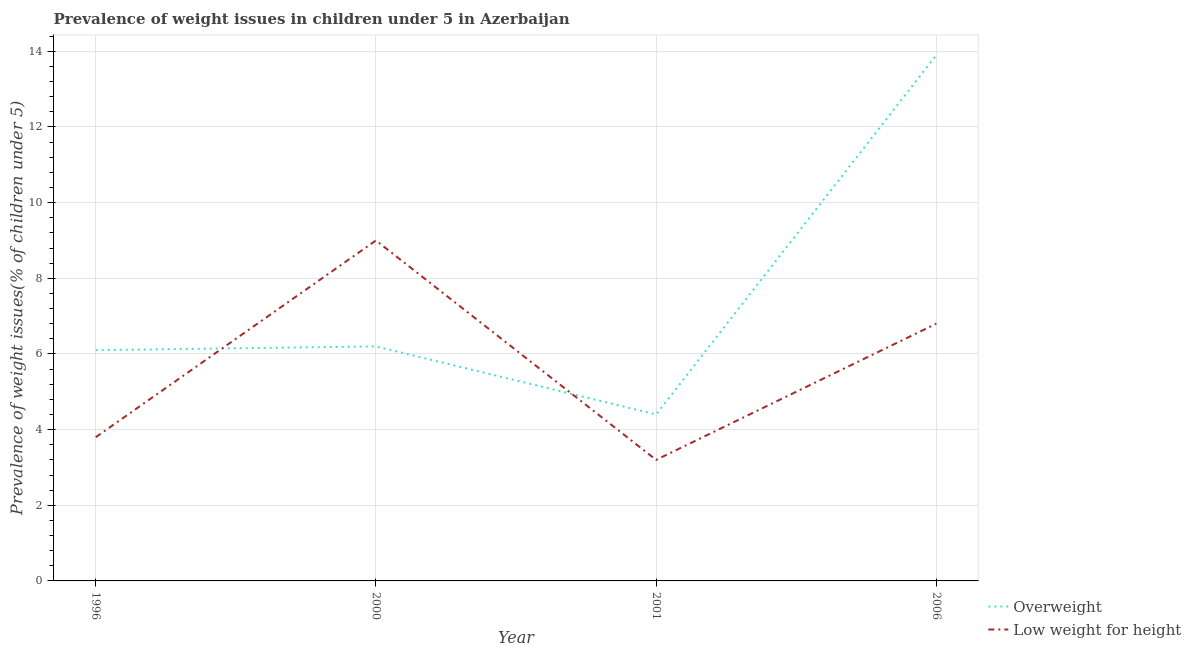What is the percentage of underweight children in 1996?
Offer a very short reply. 3.8. Across all years, what is the minimum percentage of overweight children?
Provide a short and direct response. 4.4. In which year was the percentage of overweight children maximum?
Offer a terse response. 2006. In which year was the percentage of overweight children minimum?
Give a very brief answer. 2001. What is the total percentage of underweight children in the graph?
Offer a terse response. 22.8. What is the difference between the percentage of underweight children in 1996 and that in 2000?
Your answer should be very brief. -5.2. What is the difference between the percentage of underweight children in 1996 and the percentage of overweight children in 2000?
Your answer should be compact. -2.4. What is the average percentage of underweight children per year?
Offer a very short reply. 5.7. In the year 2000, what is the difference between the percentage of overweight children and percentage of underweight children?
Your response must be concise. -2.8. In how many years, is the percentage of overweight children greater than 14 %?
Make the answer very short. 0. What is the ratio of the percentage of overweight children in 2001 to that in 2006?
Keep it short and to the point. 0.32. Is the percentage of overweight children in 1996 less than that in 2006?
Your answer should be compact. Yes. What is the difference between the highest and the second highest percentage of overweight children?
Your answer should be very brief. 7.7. What is the difference between the highest and the lowest percentage of overweight children?
Ensure brevity in your answer.  9.5. How many lines are there?
Make the answer very short. 2. How many years are there in the graph?
Make the answer very short. 4. Are the values on the major ticks of Y-axis written in scientific E-notation?
Ensure brevity in your answer.  No. Does the graph contain any zero values?
Give a very brief answer. No. Does the graph contain grids?
Your answer should be very brief. Yes. What is the title of the graph?
Give a very brief answer. Prevalence of weight issues in children under 5 in Azerbaijan. What is the label or title of the Y-axis?
Your answer should be very brief. Prevalence of weight issues(% of children under 5). What is the Prevalence of weight issues(% of children under 5) of Overweight in 1996?
Make the answer very short. 6.1. What is the Prevalence of weight issues(% of children under 5) in Low weight for height in 1996?
Provide a short and direct response. 3.8. What is the Prevalence of weight issues(% of children under 5) in Overweight in 2000?
Provide a succinct answer. 6.2. What is the Prevalence of weight issues(% of children under 5) in Low weight for height in 2000?
Offer a very short reply. 9. What is the Prevalence of weight issues(% of children under 5) of Overweight in 2001?
Provide a succinct answer. 4.4. What is the Prevalence of weight issues(% of children under 5) in Low weight for height in 2001?
Your response must be concise. 3.2. What is the Prevalence of weight issues(% of children under 5) in Overweight in 2006?
Your answer should be very brief. 13.9. What is the Prevalence of weight issues(% of children under 5) of Low weight for height in 2006?
Your answer should be compact. 6.8. Across all years, what is the maximum Prevalence of weight issues(% of children under 5) in Overweight?
Give a very brief answer. 13.9. Across all years, what is the maximum Prevalence of weight issues(% of children under 5) of Low weight for height?
Make the answer very short. 9. Across all years, what is the minimum Prevalence of weight issues(% of children under 5) of Overweight?
Offer a very short reply. 4.4. Across all years, what is the minimum Prevalence of weight issues(% of children under 5) of Low weight for height?
Your answer should be very brief. 3.2. What is the total Prevalence of weight issues(% of children under 5) of Overweight in the graph?
Give a very brief answer. 30.6. What is the total Prevalence of weight issues(% of children under 5) in Low weight for height in the graph?
Keep it short and to the point. 22.8. What is the difference between the Prevalence of weight issues(% of children under 5) of Overweight in 1996 and that in 2000?
Provide a succinct answer. -0.1. What is the difference between the Prevalence of weight issues(% of children under 5) in Overweight in 1996 and that in 2001?
Give a very brief answer. 1.7. What is the difference between the Prevalence of weight issues(% of children under 5) in Overweight in 2000 and that in 2001?
Your answer should be very brief. 1.8. What is the difference between the Prevalence of weight issues(% of children under 5) in Overweight in 2000 and that in 2006?
Offer a terse response. -7.7. What is the difference between the Prevalence of weight issues(% of children under 5) in Low weight for height in 2000 and that in 2006?
Your answer should be very brief. 2.2. What is the difference between the Prevalence of weight issues(% of children under 5) in Overweight in 2001 and that in 2006?
Keep it short and to the point. -9.5. What is the difference between the Prevalence of weight issues(% of children under 5) in Low weight for height in 2001 and that in 2006?
Your answer should be compact. -3.6. What is the difference between the Prevalence of weight issues(% of children under 5) of Overweight in 1996 and the Prevalence of weight issues(% of children under 5) of Low weight for height in 2000?
Offer a terse response. -2.9. What is the difference between the Prevalence of weight issues(% of children under 5) in Overweight in 1996 and the Prevalence of weight issues(% of children under 5) in Low weight for height in 2001?
Keep it short and to the point. 2.9. What is the difference between the Prevalence of weight issues(% of children under 5) of Overweight in 2000 and the Prevalence of weight issues(% of children under 5) of Low weight for height in 2001?
Your answer should be very brief. 3. What is the difference between the Prevalence of weight issues(% of children under 5) in Overweight in 2001 and the Prevalence of weight issues(% of children under 5) in Low weight for height in 2006?
Provide a short and direct response. -2.4. What is the average Prevalence of weight issues(% of children under 5) of Overweight per year?
Offer a terse response. 7.65. In the year 1996, what is the difference between the Prevalence of weight issues(% of children under 5) of Overweight and Prevalence of weight issues(% of children under 5) of Low weight for height?
Make the answer very short. 2.3. In the year 2000, what is the difference between the Prevalence of weight issues(% of children under 5) in Overweight and Prevalence of weight issues(% of children under 5) in Low weight for height?
Keep it short and to the point. -2.8. In the year 2001, what is the difference between the Prevalence of weight issues(% of children under 5) of Overweight and Prevalence of weight issues(% of children under 5) of Low weight for height?
Provide a succinct answer. 1.2. What is the ratio of the Prevalence of weight issues(% of children under 5) in Overweight in 1996 to that in 2000?
Your answer should be compact. 0.98. What is the ratio of the Prevalence of weight issues(% of children under 5) of Low weight for height in 1996 to that in 2000?
Your response must be concise. 0.42. What is the ratio of the Prevalence of weight issues(% of children under 5) in Overweight in 1996 to that in 2001?
Give a very brief answer. 1.39. What is the ratio of the Prevalence of weight issues(% of children under 5) of Low weight for height in 1996 to that in 2001?
Your answer should be compact. 1.19. What is the ratio of the Prevalence of weight issues(% of children under 5) of Overweight in 1996 to that in 2006?
Keep it short and to the point. 0.44. What is the ratio of the Prevalence of weight issues(% of children under 5) in Low weight for height in 1996 to that in 2006?
Your answer should be compact. 0.56. What is the ratio of the Prevalence of weight issues(% of children under 5) of Overweight in 2000 to that in 2001?
Offer a terse response. 1.41. What is the ratio of the Prevalence of weight issues(% of children under 5) of Low weight for height in 2000 to that in 2001?
Keep it short and to the point. 2.81. What is the ratio of the Prevalence of weight issues(% of children under 5) in Overweight in 2000 to that in 2006?
Your answer should be compact. 0.45. What is the ratio of the Prevalence of weight issues(% of children under 5) in Low weight for height in 2000 to that in 2006?
Your answer should be compact. 1.32. What is the ratio of the Prevalence of weight issues(% of children under 5) of Overweight in 2001 to that in 2006?
Your answer should be very brief. 0.32. What is the ratio of the Prevalence of weight issues(% of children under 5) of Low weight for height in 2001 to that in 2006?
Offer a terse response. 0.47. What is the difference between the highest and the second highest Prevalence of weight issues(% of children under 5) in Overweight?
Offer a very short reply. 7.7. What is the difference between the highest and the second highest Prevalence of weight issues(% of children under 5) of Low weight for height?
Your response must be concise. 2.2. 